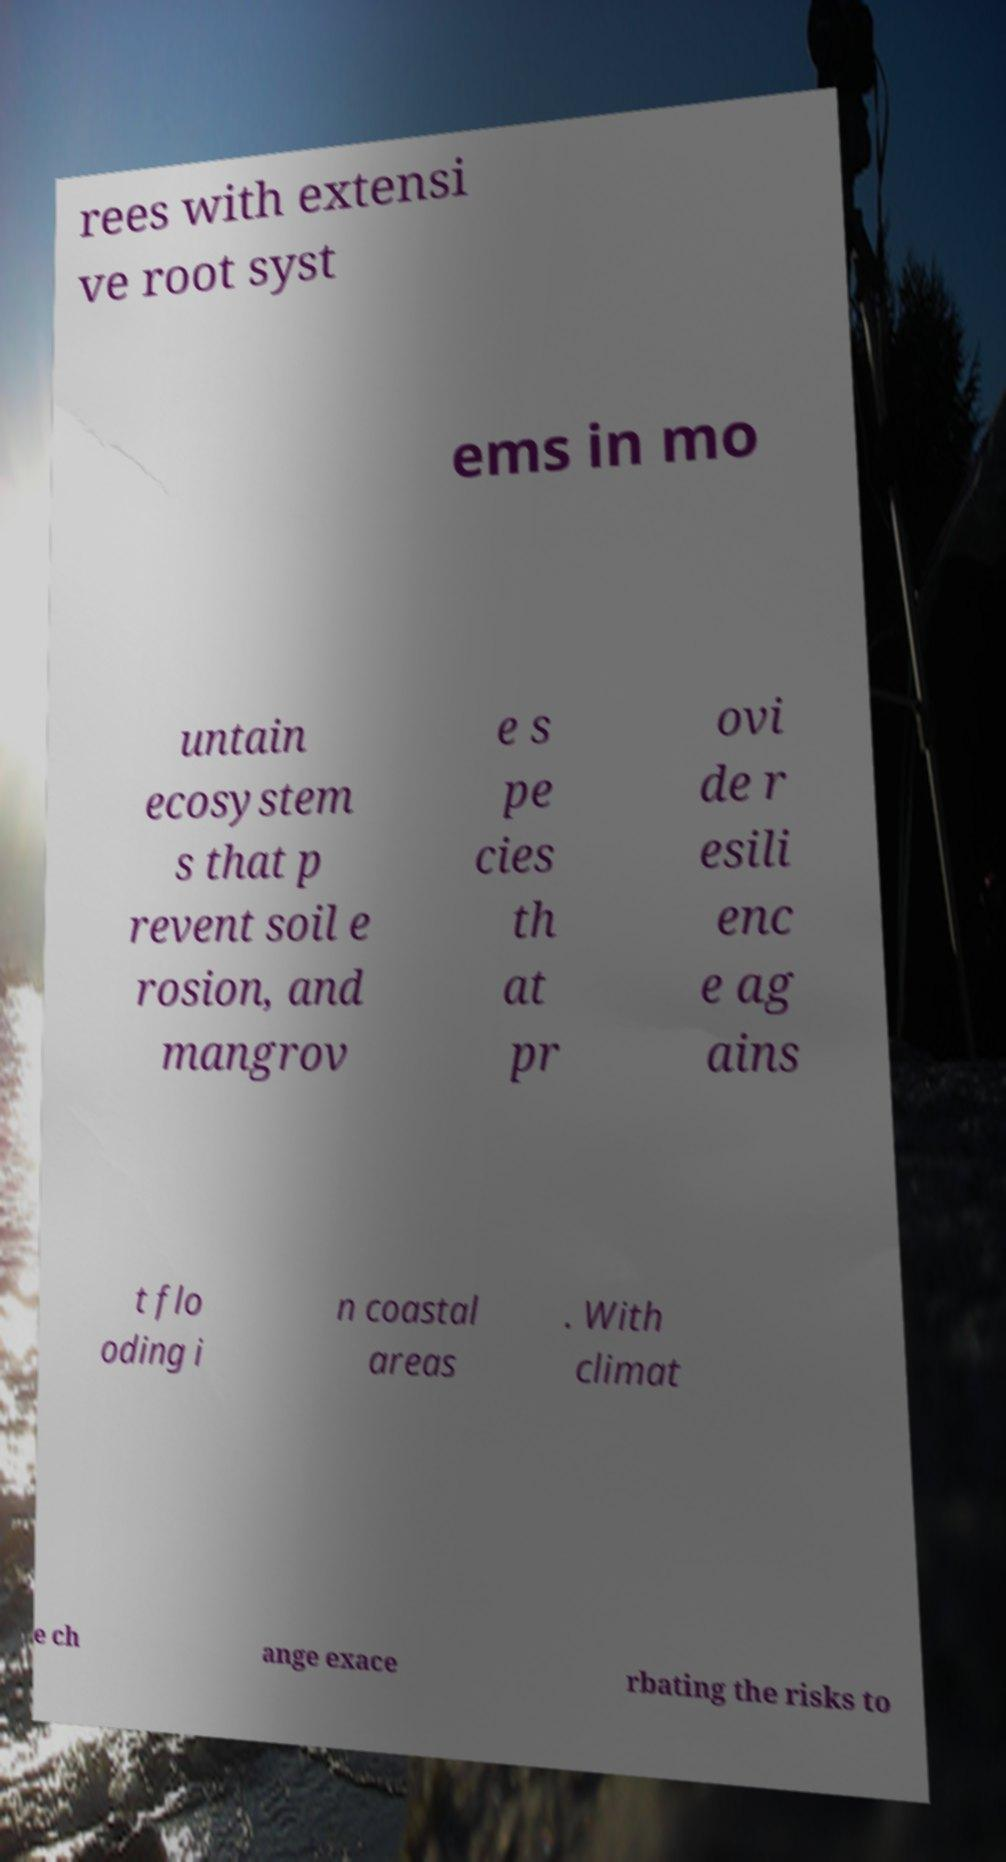Please read and relay the text visible in this image. What does it say? rees with extensi ve root syst ems in mo untain ecosystem s that p revent soil e rosion, and mangrov e s pe cies th at pr ovi de r esili enc e ag ains t flo oding i n coastal areas . With climat e ch ange exace rbating the risks to 